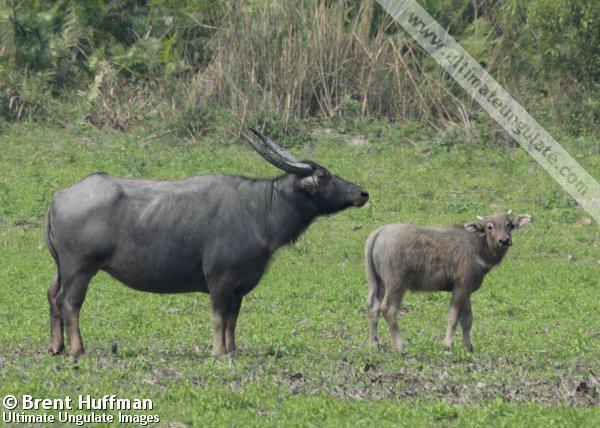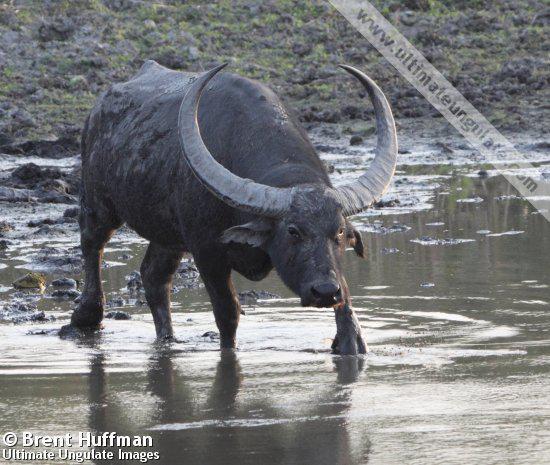The first image is the image on the left, the second image is the image on the right. For the images shown, is this caption "An image shows exactly one water buffalo standing on muddy, wet ground." true? Answer yes or no. Yes. The first image is the image on the left, the second image is the image on the right. Examine the images to the left and right. Is the description "Two cows are standing in a watery area." accurate? Answer yes or no. No. 